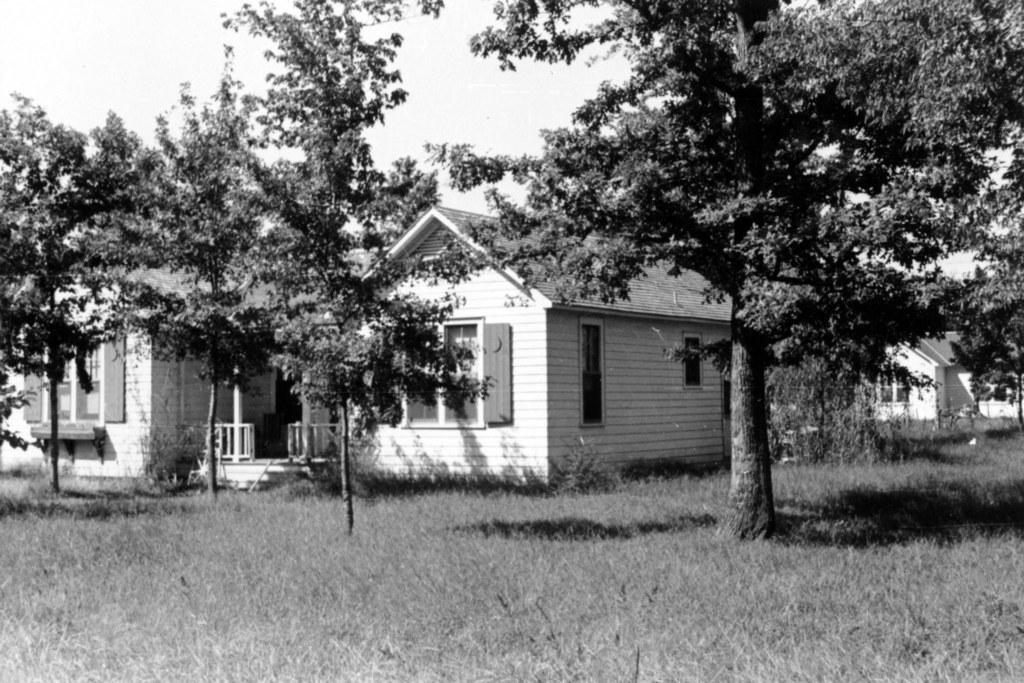What type of vegetation is present in the image? There are many trees in the image. What else can be seen on the ground in the image? There is grass visible in the image. Are there any structures near the trees? Yes, there are houses near the trees. What is visible in the background of the image? The sky is visible in the background of the image. What is the color scheme of the image? The image is black and white. What type of whip can be seen in the image? There is no whip present in the image. How many cents are visible in the image? There are no cents present in the image. 